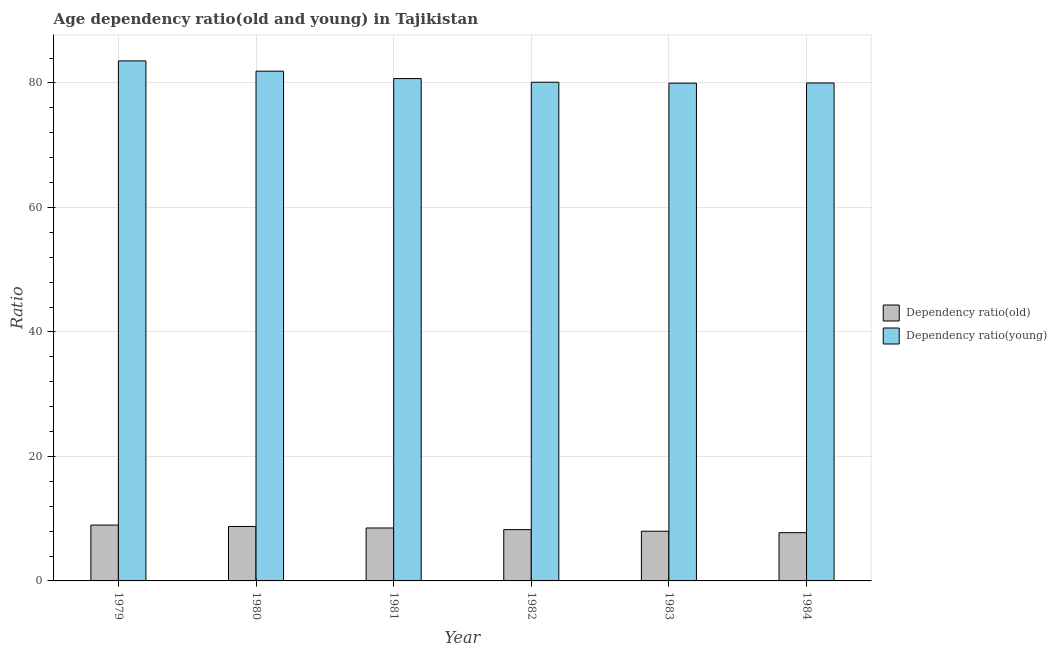How many different coloured bars are there?
Give a very brief answer. 2. Are the number of bars per tick equal to the number of legend labels?
Your response must be concise. Yes. How many bars are there on the 6th tick from the left?
Give a very brief answer. 2. What is the age dependency ratio(old) in 1982?
Your answer should be very brief. 8.24. Across all years, what is the maximum age dependency ratio(young)?
Keep it short and to the point. 83.54. Across all years, what is the minimum age dependency ratio(old)?
Your response must be concise. 7.75. In which year was the age dependency ratio(old) maximum?
Offer a terse response. 1979. In which year was the age dependency ratio(young) minimum?
Ensure brevity in your answer.  1983. What is the total age dependency ratio(young) in the graph?
Provide a short and direct response. 486.2. What is the difference between the age dependency ratio(young) in 1980 and that in 1984?
Keep it short and to the point. 1.89. What is the difference between the age dependency ratio(old) in 1979 and the age dependency ratio(young) in 1980?
Make the answer very short. 0.22. What is the average age dependency ratio(old) per year?
Make the answer very short. 8.37. In the year 1984, what is the difference between the age dependency ratio(old) and age dependency ratio(young)?
Keep it short and to the point. 0. In how many years, is the age dependency ratio(old) greater than 4?
Offer a terse response. 6. What is the ratio of the age dependency ratio(old) in 1980 to that in 1984?
Your answer should be very brief. 1.13. Is the age dependency ratio(old) in 1980 less than that in 1984?
Keep it short and to the point. No. Is the difference between the age dependency ratio(old) in 1980 and 1981 greater than the difference between the age dependency ratio(young) in 1980 and 1981?
Give a very brief answer. No. What is the difference between the highest and the second highest age dependency ratio(old)?
Keep it short and to the point. 0.22. What is the difference between the highest and the lowest age dependency ratio(old)?
Your response must be concise. 1.22. In how many years, is the age dependency ratio(old) greater than the average age dependency ratio(old) taken over all years?
Offer a terse response. 3. What does the 1st bar from the left in 1983 represents?
Provide a succinct answer. Dependency ratio(old). What does the 2nd bar from the right in 1984 represents?
Give a very brief answer. Dependency ratio(old). How many bars are there?
Your answer should be very brief. 12. Are all the bars in the graph horizontal?
Keep it short and to the point. No. Are the values on the major ticks of Y-axis written in scientific E-notation?
Provide a short and direct response. No. Does the graph contain any zero values?
Make the answer very short. No. Does the graph contain grids?
Provide a succinct answer. Yes. What is the title of the graph?
Offer a very short reply. Age dependency ratio(old and young) in Tajikistan. What is the label or title of the Y-axis?
Ensure brevity in your answer.  Ratio. What is the Ratio of Dependency ratio(old) in 1979?
Offer a very short reply. 8.97. What is the Ratio of Dependency ratio(young) in 1979?
Provide a short and direct response. 83.54. What is the Ratio in Dependency ratio(old) in 1980?
Provide a succinct answer. 8.75. What is the Ratio of Dependency ratio(young) in 1980?
Ensure brevity in your answer.  81.89. What is the Ratio of Dependency ratio(old) in 1981?
Your answer should be very brief. 8.51. What is the Ratio in Dependency ratio(young) in 1981?
Your answer should be very brief. 80.7. What is the Ratio of Dependency ratio(old) in 1982?
Your response must be concise. 8.24. What is the Ratio in Dependency ratio(young) in 1982?
Provide a short and direct response. 80.11. What is the Ratio of Dependency ratio(old) in 1983?
Keep it short and to the point. 7.98. What is the Ratio in Dependency ratio(young) in 1983?
Provide a short and direct response. 79.96. What is the Ratio of Dependency ratio(old) in 1984?
Your answer should be very brief. 7.75. What is the Ratio of Dependency ratio(young) in 1984?
Ensure brevity in your answer.  79.99. Across all years, what is the maximum Ratio in Dependency ratio(old)?
Offer a terse response. 8.97. Across all years, what is the maximum Ratio of Dependency ratio(young)?
Your answer should be compact. 83.54. Across all years, what is the minimum Ratio in Dependency ratio(old)?
Ensure brevity in your answer.  7.75. Across all years, what is the minimum Ratio in Dependency ratio(young)?
Keep it short and to the point. 79.96. What is the total Ratio in Dependency ratio(old) in the graph?
Your response must be concise. 50.2. What is the total Ratio in Dependency ratio(young) in the graph?
Offer a terse response. 486.2. What is the difference between the Ratio in Dependency ratio(old) in 1979 and that in 1980?
Offer a very short reply. 0.22. What is the difference between the Ratio of Dependency ratio(young) in 1979 and that in 1980?
Make the answer very short. 1.65. What is the difference between the Ratio in Dependency ratio(old) in 1979 and that in 1981?
Keep it short and to the point. 0.47. What is the difference between the Ratio of Dependency ratio(young) in 1979 and that in 1981?
Offer a terse response. 2.84. What is the difference between the Ratio of Dependency ratio(old) in 1979 and that in 1982?
Provide a short and direct response. 0.73. What is the difference between the Ratio of Dependency ratio(young) in 1979 and that in 1982?
Your response must be concise. 3.43. What is the difference between the Ratio of Dependency ratio(young) in 1979 and that in 1983?
Ensure brevity in your answer.  3.58. What is the difference between the Ratio in Dependency ratio(old) in 1979 and that in 1984?
Give a very brief answer. 1.22. What is the difference between the Ratio of Dependency ratio(young) in 1979 and that in 1984?
Give a very brief answer. 3.55. What is the difference between the Ratio of Dependency ratio(old) in 1980 and that in 1981?
Your answer should be compact. 0.24. What is the difference between the Ratio of Dependency ratio(young) in 1980 and that in 1981?
Keep it short and to the point. 1.19. What is the difference between the Ratio in Dependency ratio(old) in 1980 and that in 1982?
Keep it short and to the point. 0.51. What is the difference between the Ratio of Dependency ratio(young) in 1980 and that in 1982?
Ensure brevity in your answer.  1.78. What is the difference between the Ratio of Dependency ratio(old) in 1980 and that in 1983?
Make the answer very short. 0.77. What is the difference between the Ratio in Dependency ratio(young) in 1980 and that in 1983?
Your answer should be very brief. 1.92. What is the difference between the Ratio in Dependency ratio(young) in 1980 and that in 1984?
Provide a succinct answer. 1.89. What is the difference between the Ratio in Dependency ratio(old) in 1981 and that in 1982?
Your answer should be compact. 0.26. What is the difference between the Ratio of Dependency ratio(young) in 1981 and that in 1982?
Offer a terse response. 0.59. What is the difference between the Ratio in Dependency ratio(old) in 1981 and that in 1983?
Keep it short and to the point. 0.52. What is the difference between the Ratio in Dependency ratio(young) in 1981 and that in 1983?
Offer a terse response. 0.73. What is the difference between the Ratio of Dependency ratio(old) in 1981 and that in 1984?
Ensure brevity in your answer.  0.75. What is the difference between the Ratio of Dependency ratio(young) in 1981 and that in 1984?
Offer a very short reply. 0.7. What is the difference between the Ratio of Dependency ratio(old) in 1982 and that in 1983?
Provide a succinct answer. 0.26. What is the difference between the Ratio in Dependency ratio(young) in 1982 and that in 1983?
Ensure brevity in your answer.  0.14. What is the difference between the Ratio in Dependency ratio(old) in 1982 and that in 1984?
Keep it short and to the point. 0.49. What is the difference between the Ratio of Dependency ratio(young) in 1982 and that in 1984?
Offer a very short reply. 0.12. What is the difference between the Ratio of Dependency ratio(old) in 1983 and that in 1984?
Keep it short and to the point. 0.23. What is the difference between the Ratio of Dependency ratio(young) in 1983 and that in 1984?
Provide a short and direct response. -0.03. What is the difference between the Ratio in Dependency ratio(old) in 1979 and the Ratio in Dependency ratio(young) in 1980?
Offer a terse response. -72.92. What is the difference between the Ratio of Dependency ratio(old) in 1979 and the Ratio of Dependency ratio(young) in 1981?
Your answer should be compact. -71.73. What is the difference between the Ratio of Dependency ratio(old) in 1979 and the Ratio of Dependency ratio(young) in 1982?
Your answer should be very brief. -71.14. What is the difference between the Ratio in Dependency ratio(old) in 1979 and the Ratio in Dependency ratio(young) in 1983?
Your response must be concise. -70.99. What is the difference between the Ratio of Dependency ratio(old) in 1979 and the Ratio of Dependency ratio(young) in 1984?
Your response must be concise. -71.02. What is the difference between the Ratio in Dependency ratio(old) in 1980 and the Ratio in Dependency ratio(young) in 1981?
Offer a terse response. -71.95. What is the difference between the Ratio of Dependency ratio(old) in 1980 and the Ratio of Dependency ratio(young) in 1982?
Keep it short and to the point. -71.36. What is the difference between the Ratio of Dependency ratio(old) in 1980 and the Ratio of Dependency ratio(young) in 1983?
Make the answer very short. -71.21. What is the difference between the Ratio of Dependency ratio(old) in 1980 and the Ratio of Dependency ratio(young) in 1984?
Your answer should be very brief. -71.24. What is the difference between the Ratio of Dependency ratio(old) in 1981 and the Ratio of Dependency ratio(young) in 1982?
Ensure brevity in your answer.  -71.6. What is the difference between the Ratio of Dependency ratio(old) in 1981 and the Ratio of Dependency ratio(young) in 1983?
Give a very brief answer. -71.46. What is the difference between the Ratio in Dependency ratio(old) in 1981 and the Ratio in Dependency ratio(young) in 1984?
Your answer should be compact. -71.49. What is the difference between the Ratio in Dependency ratio(old) in 1982 and the Ratio in Dependency ratio(young) in 1983?
Keep it short and to the point. -71.72. What is the difference between the Ratio of Dependency ratio(old) in 1982 and the Ratio of Dependency ratio(young) in 1984?
Offer a terse response. -71.75. What is the difference between the Ratio in Dependency ratio(old) in 1983 and the Ratio in Dependency ratio(young) in 1984?
Provide a succinct answer. -72.01. What is the average Ratio in Dependency ratio(old) per year?
Your answer should be compact. 8.37. What is the average Ratio in Dependency ratio(young) per year?
Offer a very short reply. 81.03. In the year 1979, what is the difference between the Ratio in Dependency ratio(old) and Ratio in Dependency ratio(young)?
Your response must be concise. -74.57. In the year 1980, what is the difference between the Ratio in Dependency ratio(old) and Ratio in Dependency ratio(young)?
Provide a succinct answer. -73.14. In the year 1981, what is the difference between the Ratio in Dependency ratio(old) and Ratio in Dependency ratio(young)?
Your answer should be compact. -72.19. In the year 1982, what is the difference between the Ratio of Dependency ratio(old) and Ratio of Dependency ratio(young)?
Keep it short and to the point. -71.87. In the year 1983, what is the difference between the Ratio in Dependency ratio(old) and Ratio in Dependency ratio(young)?
Give a very brief answer. -71.98. In the year 1984, what is the difference between the Ratio in Dependency ratio(old) and Ratio in Dependency ratio(young)?
Your answer should be very brief. -72.24. What is the ratio of the Ratio of Dependency ratio(old) in 1979 to that in 1980?
Your answer should be compact. 1.03. What is the ratio of the Ratio in Dependency ratio(young) in 1979 to that in 1980?
Make the answer very short. 1.02. What is the ratio of the Ratio in Dependency ratio(old) in 1979 to that in 1981?
Provide a short and direct response. 1.05. What is the ratio of the Ratio of Dependency ratio(young) in 1979 to that in 1981?
Your answer should be compact. 1.04. What is the ratio of the Ratio in Dependency ratio(old) in 1979 to that in 1982?
Provide a succinct answer. 1.09. What is the ratio of the Ratio of Dependency ratio(young) in 1979 to that in 1982?
Provide a short and direct response. 1.04. What is the ratio of the Ratio of Dependency ratio(old) in 1979 to that in 1983?
Offer a terse response. 1.12. What is the ratio of the Ratio of Dependency ratio(young) in 1979 to that in 1983?
Offer a very short reply. 1.04. What is the ratio of the Ratio of Dependency ratio(old) in 1979 to that in 1984?
Offer a terse response. 1.16. What is the ratio of the Ratio of Dependency ratio(young) in 1979 to that in 1984?
Give a very brief answer. 1.04. What is the ratio of the Ratio in Dependency ratio(old) in 1980 to that in 1981?
Make the answer very short. 1.03. What is the ratio of the Ratio of Dependency ratio(young) in 1980 to that in 1981?
Ensure brevity in your answer.  1.01. What is the ratio of the Ratio of Dependency ratio(old) in 1980 to that in 1982?
Keep it short and to the point. 1.06. What is the ratio of the Ratio in Dependency ratio(young) in 1980 to that in 1982?
Offer a terse response. 1.02. What is the ratio of the Ratio of Dependency ratio(old) in 1980 to that in 1983?
Offer a terse response. 1.1. What is the ratio of the Ratio in Dependency ratio(young) in 1980 to that in 1983?
Ensure brevity in your answer.  1.02. What is the ratio of the Ratio of Dependency ratio(old) in 1980 to that in 1984?
Offer a terse response. 1.13. What is the ratio of the Ratio of Dependency ratio(young) in 1980 to that in 1984?
Give a very brief answer. 1.02. What is the ratio of the Ratio of Dependency ratio(old) in 1981 to that in 1982?
Provide a short and direct response. 1.03. What is the ratio of the Ratio in Dependency ratio(young) in 1981 to that in 1982?
Your response must be concise. 1.01. What is the ratio of the Ratio of Dependency ratio(old) in 1981 to that in 1983?
Provide a short and direct response. 1.07. What is the ratio of the Ratio in Dependency ratio(young) in 1981 to that in 1983?
Offer a very short reply. 1.01. What is the ratio of the Ratio of Dependency ratio(old) in 1981 to that in 1984?
Offer a very short reply. 1.1. What is the ratio of the Ratio in Dependency ratio(young) in 1981 to that in 1984?
Give a very brief answer. 1.01. What is the ratio of the Ratio of Dependency ratio(old) in 1982 to that in 1983?
Keep it short and to the point. 1.03. What is the ratio of the Ratio of Dependency ratio(young) in 1982 to that in 1983?
Provide a succinct answer. 1. What is the ratio of the Ratio in Dependency ratio(old) in 1982 to that in 1984?
Your answer should be very brief. 1.06. What is the ratio of the Ratio of Dependency ratio(young) in 1982 to that in 1984?
Offer a terse response. 1. What is the ratio of the Ratio of Dependency ratio(old) in 1983 to that in 1984?
Give a very brief answer. 1.03. What is the difference between the highest and the second highest Ratio in Dependency ratio(old)?
Give a very brief answer. 0.22. What is the difference between the highest and the second highest Ratio of Dependency ratio(young)?
Your answer should be very brief. 1.65. What is the difference between the highest and the lowest Ratio in Dependency ratio(old)?
Give a very brief answer. 1.22. What is the difference between the highest and the lowest Ratio in Dependency ratio(young)?
Make the answer very short. 3.58. 